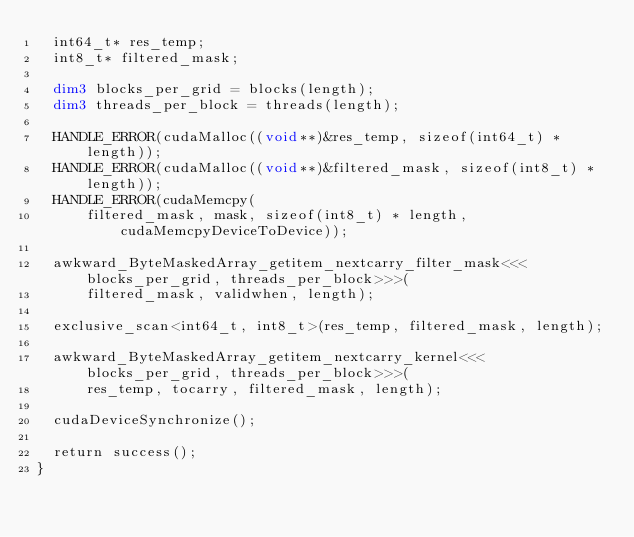<code> <loc_0><loc_0><loc_500><loc_500><_Cuda_>  int64_t* res_temp;
  int8_t* filtered_mask;

  dim3 blocks_per_grid = blocks(length);
  dim3 threads_per_block = threads(length);

  HANDLE_ERROR(cudaMalloc((void**)&res_temp, sizeof(int64_t) * length));
  HANDLE_ERROR(cudaMalloc((void**)&filtered_mask, sizeof(int8_t) * length));
  HANDLE_ERROR(cudaMemcpy(
      filtered_mask, mask, sizeof(int8_t) * length, cudaMemcpyDeviceToDevice));

  awkward_ByteMaskedArray_getitem_nextcarry_filter_mask<<<blocks_per_grid, threads_per_block>>>(
      filtered_mask, validwhen, length);

  exclusive_scan<int64_t, int8_t>(res_temp, filtered_mask, length);

  awkward_ByteMaskedArray_getitem_nextcarry_kernel<<<blocks_per_grid, threads_per_block>>>(
      res_temp, tocarry, filtered_mask, length);

  cudaDeviceSynchronize();

  return success();
}
</code> 